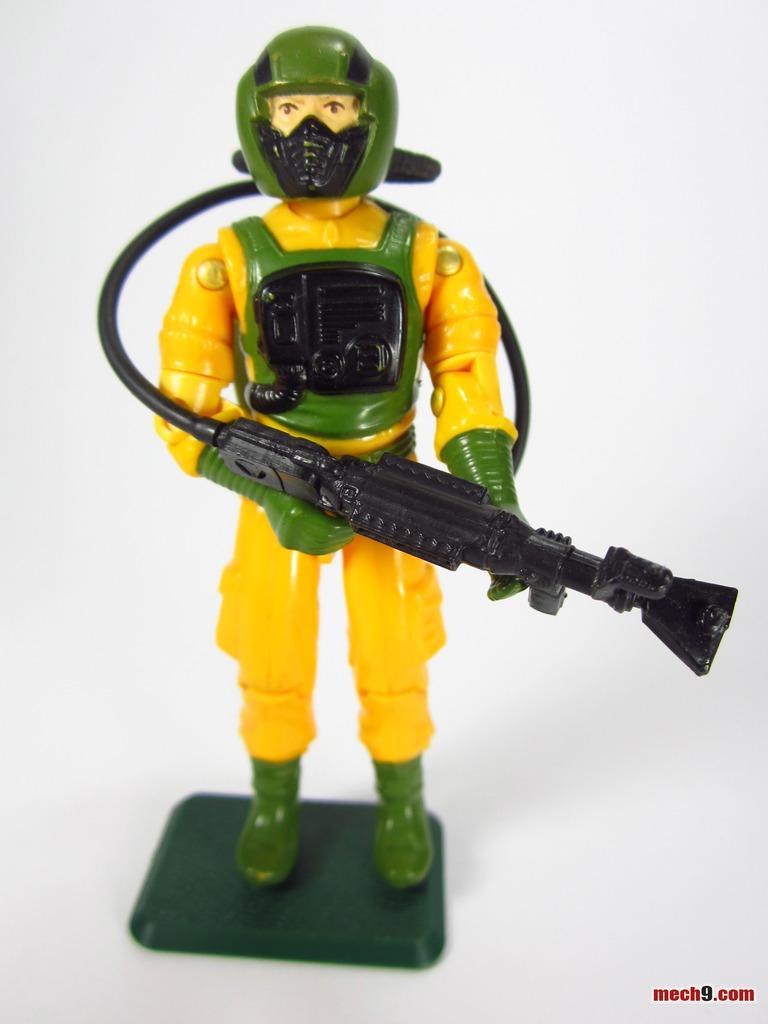In one or two sentences, can you explain what this image depicts? In this picture there is a toy who is holding a plastic gun. This toy is kept on the table. In the bottom right corner there is a watermark. 